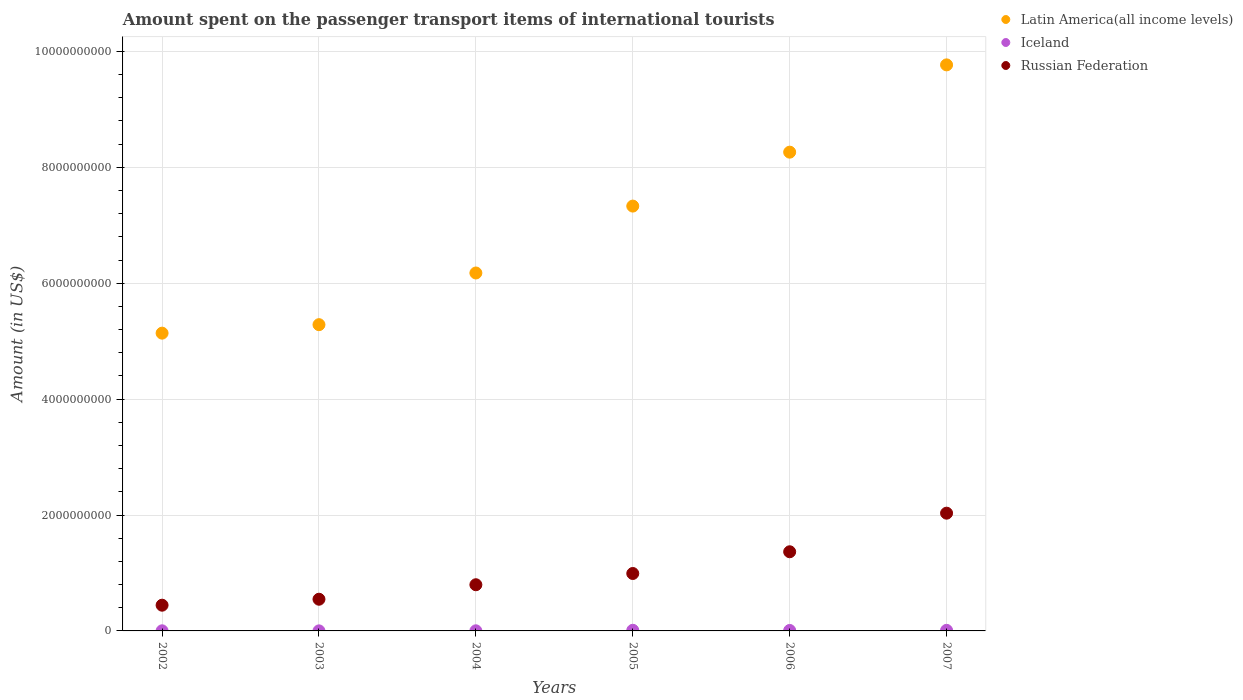How many different coloured dotlines are there?
Give a very brief answer. 3. What is the amount spent on the passenger transport items of international tourists in Russian Federation in 2002?
Offer a terse response. 4.44e+08. Across all years, what is the maximum amount spent on the passenger transport items of international tourists in Iceland?
Provide a succinct answer. 1.10e+07. In which year was the amount spent on the passenger transport items of international tourists in Latin America(all income levels) maximum?
Your answer should be very brief. 2007. What is the total amount spent on the passenger transport items of international tourists in Russian Federation in the graph?
Your answer should be very brief. 6.18e+09. What is the difference between the amount spent on the passenger transport items of international tourists in Latin America(all income levels) in 2003 and that in 2007?
Provide a succinct answer. -4.48e+09. What is the difference between the amount spent on the passenger transport items of international tourists in Iceland in 2006 and the amount spent on the passenger transport items of international tourists in Latin America(all income levels) in 2002?
Ensure brevity in your answer.  -5.13e+09. What is the average amount spent on the passenger transport items of international tourists in Iceland per year?
Give a very brief answer. 5.67e+06. In the year 2004, what is the difference between the amount spent on the passenger transport items of international tourists in Latin America(all income levels) and amount spent on the passenger transport items of international tourists in Iceland?
Offer a very short reply. 6.17e+09. What is the ratio of the amount spent on the passenger transport items of international tourists in Russian Federation in 2003 to that in 2004?
Keep it short and to the point. 0.69. Is the amount spent on the passenger transport items of international tourists in Russian Federation in 2003 less than that in 2007?
Your response must be concise. Yes. Is the difference between the amount spent on the passenger transport items of international tourists in Latin America(all income levels) in 2002 and 2006 greater than the difference between the amount spent on the passenger transport items of international tourists in Iceland in 2002 and 2006?
Provide a short and direct response. No. What is the difference between the highest and the second highest amount spent on the passenger transport items of international tourists in Russian Federation?
Offer a very short reply. 6.66e+08. Is the sum of the amount spent on the passenger transport items of international tourists in Iceland in 2005 and 2007 greater than the maximum amount spent on the passenger transport items of international tourists in Russian Federation across all years?
Your response must be concise. No. Is it the case that in every year, the sum of the amount spent on the passenger transport items of international tourists in Iceland and amount spent on the passenger transport items of international tourists in Russian Federation  is greater than the amount spent on the passenger transport items of international tourists in Latin America(all income levels)?
Your answer should be compact. No. Is the amount spent on the passenger transport items of international tourists in Russian Federation strictly greater than the amount spent on the passenger transport items of international tourists in Latin America(all income levels) over the years?
Make the answer very short. No. Is the amount spent on the passenger transport items of international tourists in Latin America(all income levels) strictly less than the amount spent on the passenger transport items of international tourists in Iceland over the years?
Offer a very short reply. No. How many years are there in the graph?
Ensure brevity in your answer.  6. What is the difference between two consecutive major ticks on the Y-axis?
Keep it short and to the point. 2.00e+09. Are the values on the major ticks of Y-axis written in scientific E-notation?
Ensure brevity in your answer.  No. Does the graph contain grids?
Offer a very short reply. Yes. How many legend labels are there?
Your answer should be compact. 3. How are the legend labels stacked?
Offer a terse response. Vertical. What is the title of the graph?
Ensure brevity in your answer.  Amount spent on the passenger transport items of international tourists. What is the label or title of the Y-axis?
Offer a very short reply. Amount (in US$). What is the Amount (in US$) of Latin America(all income levels) in 2002?
Offer a terse response. 5.14e+09. What is the Amount (in US$) in Russian Federation in 2002?
Offer a terse response. 4.44e+08. What is the Amount (in US$) in Latin America(all income levels) in 2003?
Ensure brevity in your answer.  5.29e+09. What is the Amount (in US$) in Iceland in 2003?
Offer a very short reply. 1.00e+06. What is the Amount (in US$) of Russian Federation in 2003?
Your response must be concise. 5.47e+08. What is the Amount (in US$) of Latin America(all income levels) in 2004?
Your answer should be compact. 6.18e+09. What is the Amount (in US$) of Iceland in 2004?
Your answer should be very brief. 2.00e+06. What is the Amount (in US$) of Russian Federation in 2004?
Offer a very short reply. 7.97e+08. What is the Amount (in US$) of Latin America(all income levels) in 2005?
Your answer should be compact. 7.33e+09. What is the Amount (in US$) of Iceland in 2005?
Your answer should be compact. 1.10e+07. What is the Amount (in US$) in Russian Federation in 2005?
Ensure brevity in your answer.  9.91e+08. What is the Amount (in US$) of Latin America(all income levels) in 2006?
Provide a short and direct response. 8.26e+09. What is the Amount (in US$) in Iceland in 2006?
Offer a very short reply. 8.00e+06. What is the Amount (in US$) of Russian Federation in 2006?
Offer a terse response. 1.37e+09. What is the Amount (in US$) of Latin America(all income levels) in 2007?
Provide a succinct answer. 9.77e+09. What is the Amount (in US$) in Iceland in 2007?
Provide a succinct answer. 1.00e+07. What is the Amount (in US$) in Russian Federation in 2007?
Offer a terse response. 2.03e+09. Across all years, what is the maximum Amount (in US$) in Latin America(all income levels)?
Ensure brevity in your answer.  9.77e+09. Across all years, what is the maximum Amount (in US$) of Iceland?
Your answer should be very brief. 1.10e+07. Across all years, what is the maximum Amount (in US$) in Russian Federation?
Provide a short and direct response. 2.03e+09. Across all years, what is the minimum Amount (in US$) in Latin America(all income levels)?
Ensure brevity in your answer.  5.14e+09. Across all years, what is the minimum Amount (in US$) in Russian Federation?
Make the answer very short. 4.44e+08. What is the total Amount (in US$) in Latin America(all income levels) in the graph?
Your response must be concise. 4.20e+1. What is the total Amount (in US$) in Iceland in the graph?
Ensure brevity in your answer.  3.40e+07. What is the total Amount (in US$) in Russian Federation in the graph?
Offer a terse response. 6.18e+09. What is the difference between the Amount (in US$) in Latin America(all income levels) in 2002 and that in 2003?
Your answer should be compact. -1.46e+08. What is the difference between the Amount (in US$) of Russian Federation in 2002 and that in 2003?
Your answer should be very brief. -1.03e+08. What is the difference between the Amount (in US$) in Latin America(all income levels) in 2002 and that in 2004?
Ensure brevity in your answer.  -1.04e+09. What is the difference between the Amount (in US$) in Iceland in 2002 and that in 2004?
Make the answer very short. 0. What is the difference between the Amount (in US$) in Russian Federation in 2002 and that in 2004?
Offer a terse response. -3.53e+08. What is the difference between the Amount (in US$) of Latin America(all income levels) in 2002 and that in 2005?
Offer a very short reply. -2.19e+09. What is the difference between the Amount (in US$) of Iceland in 2002 and that in 2005?
Ensure brevity in your answer.  -9.00e+06. What is the difference between the Amount (in US$) in Russian Federation in 2002 and that in 2005?
Provide a short and direct response. -5.47e+08. What is the difference between the Amount (in US$) in Latin America(all income levels) in 2002 and that in 2006?
Make the answer very short. -3.12e+09. What is the difference between the Amount (in US$) in Iceland in 2002 and that in 2006?
Provide a succinct answer. -6.00e+06. What is the difference between the Amount (in US$) of Russian Federation in 2002 and that in 2006?
Provide a short and direct response. -9.22e+08. What is the difference between the Amount (in US$) of Latin America(all income levels) in 2002 and that in 2007?
Ensure brevity in your answer.  -4.63e+09. What is the difference between the Amount (in US$) in Iceland in 2002 and that in 2007?
Make the answer very short. -8.00e+06. What is the difference between the Amount (in US$) in Russian Federation in 2002 and that in 2007?
Keep it short and to the point. -1.59e+09. What is the difference between the Amount (in US$) in Latin America(all income levels) in 2003 and that in 2004?
Your answer should be compact. -8.92e+08. What is the difference between the Amount (in US$) of Iceland in 2003 and that in 2004?
Give a very brief answer. -1.00e+06. What is the difference between the Amount (in US$) of Russian Federation in 2003 and that in 2004?
Keep it short and to the point. -2.50e+08. What is the difference between the Amount (in US$) of Latin America(all income levels) in 2003 and that in 2005?
Your answer should be very brief. -2.05e+09. What is the difference between the Amount (in US$) of Iceland in 2003 and that in 2005?
Ensure brevity in your answer.  -1.00e+07. What is the difference between the Amount (in US$) of Russian Federation in 2003 and that in 2005?
Your response must be concise. -4.44e+08. What is the difference between the Amount (in US$) of Latin America(all income levels) in 2003 and that in 2006?
Give a very brief answer. -2.98e+09. What is the difference between the Amount (in US$) in Iceland in 2003 and that in 2006?
Your answer should be compact. -7.00e+06. What is the difference between the Amount (in US$) of Russian Federation in 2003 and that in 2006?
Ensure brevity in your answer.  -8.19e+08. What is the difference between the Amount (in US$) in Latin America(all income levels) in 2003 and that in 2007?
Offer a very short reply. -4.48e+09. What is the difference between the Amount (in US$) of Iceland in 2003 and that in 2007?
Offer a terse response. -9.00e+06. What is the difference between the Amount (in US$) in Russian Federation in 2003 and that in 2007?
Your answer should be compact. -1.48e+09. What is the difference between the Amount (in US$) in Latin America(all income levels) in 2004 and that in 2005?
Provide a short and direct response. -1.15e+09. What is the difference between the Amount (in US$) in Iceland in 2004 and that in 2005?
Keep it short and to the point. -9.00e+06. What is the difference between the Amount (in US$) of Russian Federation in 2004 and that in 2005?
Give a very brief answer. -1.94e+08. What is the difference between the Amount (in US$) of Latin America(all income levels) in 2004 and that in 2006?
Offer a very short reply. -2.09e+09. What is the difference between the Amount (in US$) of Iceland in 2004 and that in 2006?
Your answer should be very brief. -6.00e+06. What is the difference between the Amount (in US$) in Russian Federation in 2004 and that in 2006?
Offer a terse response. -5.69e+08. What is the difference between the Amount (in US$) in Latin America(all income levels) in 2004 and that in 2007?
Ensure brevity in your answer.  -3.59e+09. What is the difference between the Amount (in US$) in Iceland in 2004 and that in 2007?
Your response must be concise. -8.00e+06. What is the difference between the Amount (in US$) of Russian Federation in 2004 and that in 2007?
Your response must be concise. -1.24e+09. What is the difference between the Amount (in US$) of Latin America(all income levels) in 2005 and that in 2006?
Your answer should be very brief. -9.31e+08. What is the difference between the Amount (in US$) of Iceland in 2005 and that in 2006?
Make the answer very short. 3.00e+06. What is the difference between the Amount (in US$) of Russian Federation in 2005 and that in 2006?
Offer a very short reply. -3.75e+08. What is the difference between the Amount (in US$) of Latin America(all income levels) in 2005 and that in 2007?
Keep it short and to the point. -2.44e+09. What is the difference between the Amount (in US$) in Iceland in 2005 and that in 2007?
Keep it short and to the point. 1.00e+06. What is the difference between the Amount (in US$) of Russian Federation in 2005 and that in 2007?
Your answer should be compact. -1.04e+09. What is the difference between the Amount (in US$) in Latin America(all income levels) in 2006 and that in 2007?
Offer a terse response. -1.51e+09. What is the difference between the Amount (in US$) in Iceland in 2006 and that in 2007?
Offer a terse response. -2.00e+06. What is the difference between the Amount (in US$) in Russian Federation in 2006 and that in 2007?
Give a very brief answer. -6.66e+08. What is the difference between the Amount (in US$) in Latin America(all income levels) in 2002 and the Amount (in US$) in Iceland in 2003?
Offer a terse response. 5.14e+09. What is the difference between the Amount (in US$) in Latin America(all income levels) in 2002 and the Amount (in US$) in Russian Federation in 2003?
Keep it short and to the point. 4.59e+09. What is the difference between the Amount (in US$) of Iceland in 2002 and the Amount (in US$) of Russian Federation in 2003?
Your answer should be compact. -5.45e+08. What is the difference between the Amount (in US$) in Latin America(all income levels) in 2002 and the Amount (in US$) in Iceland in 2004?
Offer a very short reply. 5.14e+09. What is the difference between the Amount (in US$) of Latin America(all income levels) in 2002 and the Amount (in US$) of Russian Federation in 2004?
Keep it short and to the point. 4.34e+09. What is the difference between the Amount (in US$) in Iceland in 2002 and the Amount (in US$) in Russian Federation in 2004?
Offer a very short reply. -7.95e+08. What is the difference between the Amount (in US$) in Latin America(all income levels) in 2002 and the Amount (in US$) in Iceland in 2005?
Your answer should be very brief. 5.13e+09. What is the difference between the Amount (in US$) of Latin America(all income levels) in 2002 and the Amount (in US$) of Russian Federation in 2005?
Ensure brevity in your answer.  4.15e+09. What is the difference between the Amount (in US$) of Iceland in 2002 and the Amount (in US$) of Russian Federation in 2005?
Your answer should be very brief. -9.89e+08. What is the difference between the Amount (in US$) of Latin America(all income levels) in 2002 and the Amount (in US$) of Iceland in 2006?
Provide a short and direct response. 5.13e+09. What is the difference between the Amount (in US$) in Latin America(all income levels) in 2002 and the Amount (in US$) in Russian Federation in 2006?
Your answer should be compact. 3.77e+09. What is the difference between the Amount (in US$) in Iceland in 2002 and the Amount (in US$) in Russian Federation in 2006?
Offer a very short reply. -1.36e+09. What is the difference between the Amount (in US$) in Latin America(all income levels) in 2002 and the Amount (in US$) in Iceland in 2007?
Your answer should be very brief. 5.13e+09. What is the difference between the Amount (in US$) of Latin America(all income levels) in 2002 and the Amount (in US$) of Russian Federation in 2007?
Your response must be concise. 3.11e+09. What is the difference between the Amount (in US$) in Iceland in 2002 and the Amount (in US$) in Russian Federation in 2007?
Keep it short and to the point. -2.03e+09. What is the difference between the Amount (in US$) of Latin America(all income levels) in 2003 and the Amount (in US$) of Iceland in 2004?
Provide a short and direct response. 5.28e+09. What is the difference between the Amount (in US$) of Latin America(all income levels) in 2003 and the Amount (in US$) of Russian Federation in 2004?
Your response must be concise. 4.49e+09. What is the difference between the Amount (in US$) of Iceland in 2003 and the Amount (in US$) of Russian Federation in 2004?
Provide a succinct answer. -7.96e+08. What is the difference between the Amount (in US$) in Latin America(all income levels) in 2003 and the Amount (in US$) in Iceland in 2005?
Provide a short and direct response. 5.27e+09. What is the difference between the Amount (in US$) in Latin America(all income levels) in 2003 and the Amount (in US$) in Russian Federation in 2005?
Offer a very short reply. 4.29e+09. What is the difference between the Amount (in US$) in Iceland in 2003 and the Amount (in US$) in Russian Federation in 2005?
Provide a succinct answer. -9.90e+08. What is the difference between the Amount (in US$) of Latin America(all income levels) in 2003 and the Amount (in US$) of Iceland in 2006?
Provide a succinct answer. 5.28e+09. What is the difference between the Amount (in US$) in Latin America(all income levels) in 2003 and the Amount (in US$) in Russian Federation in 2006?
Provide a succinct answer. 3.92e+09. What is the difference between the Amount (in US$) in Iceland in 2003 and the Amount (in US$) in Russian Federation in 2006?
Keep it short and to the point. -1.36e+09. What is the difference between the Amount (in US$) in Latin America(all income levels) in 2003 and the Amount (in US$) in Iceland in 2007?
Your answer should be compact. 5.28e+09. What is the difference between the Amount (in US$) of Latin America(all income levels) in 2003 and the Amount (in US$) of Russian Federation in 2007?
Ensure brevity in your answer.  3.25e+09. What is the difference between the Amount (in US$) in Iceland in 2003 and the Amount (in US$) in Russian Federation in 2007?
Your response must be concise. -2.03e+09. What is the difference between the Amount (in US$) in Latin America(all income levels) in 2004 and the Amount (in US$) in Iceland in 2005?
Give a very brief answer. 6.17e+09. What is the difference between the Amount (in US$) of Latin America(all income levels) in 2004 and the Amount (in US$) of Russian Federation in 2005?
Provide a succinct answer. 5.19e+09. What is the difference between the Amount (in US$) of Iceland in 2004 and the Amount (in US$) of Russian Federation in 2005?
Make the answer very short. -9.89e+08. What is the difference between the Amount (in US$) of Latin America(all income levels) in 2004 and the Amount (in US$) of Iceland in 2006?
Offer a very short reply. 6.17e+09. What is the difference between the Amount (in US$) in Latin America(all income levels) in 2004 and the Amount (in US$) in Russian Federation in 2006?
Ensure brevity in your answer.  4.81e+09. What is the difference between the Amount (in US$) in Iceland in 2004 and the Amount (in US$) in Russian Federation in 2006?
Give a very brief answer. -1.36e+09. What is the difference between the Amount (in US$) of Latin America(all income levels) in 2004 and the Amount (in US$) of Iceland in 2007?
Give a very brief answer. 6.17e+09. What is the difference between the Amount (in US$) of Latin America(all income levels) in 2004 and the Amount (in US$) of Russian Federation in 2007?
Ensure brevity in your answer.  4.14e+09. What is the difference between the Amount (in US$) of Iceland in 2004 and the Amount (in US$) of Russian Federation in 2007?
Make the answer very short. -2.03e+09. What is the difference between the Amount (in US$) of Latin America(all income levels) in 2005 and the Amount (in US$) of Iceland in 2006?
Keep it short and to the point. 7.32e+09. What is the difference between the Amount (in US$) in Latin America(all income levels) in 2005 and the Amount (in US$) in Russian Federation in 2006?
Your response must be concise. 5.97e+09. What is the difference between the Amount (in US$) of Iceland in 2005 and the Amount (in US$) of Russian Federation in 2006?
Your response must be concise. -1.36e+09. What is the difference between the Amount (in US$) of Latin America(all income levels) in 2005 and the Amount (in US$) of Iceland in 2007?
Provide a short and direct response. 7.32e+09. What is the difference between the Amount (in US$) in Latin America(all income levels) in 2005 and the Amount (in US$) in Russian Federation in 2007?
Make the answer very short. 5.30e+09. What is the difference between the Amount (in US$) in Iceland in 2005 and the Amount (in US$) in Russian Federation in 2007?
Your answer should be compact. -2.02e+09. What is the difference between the Amount (in US$) of Latin America(all income levels) in 2006 and the Amount (in US$) of Iceland in 2007?
Keep it short and to the point. 8.25e+09. What is the difference between the Amount (in US$) in Latin America(all income levels) in 2006 and the Amount (in US$) in Russian Federation in 2007?
Give a very brief answer. 6.23e+09. What is the difference between the Amount (in US$) in Iceland in 2006 and the Amount (in US$) in Russian Federation in 2007?
Make the answer very short. -2.02e+09. What is the average Amount (in US$) in Latin America(all income levels) per year?
Your response must be concise. 6.99e+09. What is the average Amount (in US$) in Iceland per year?
Your answer should be compact. 5.67e+06. What is the average Amount (in US$) of Russian Federation per year?
Provide a succinct answer. 1.03e+09. In the year 2002, what is the difference between the Amount (in US$) in Latin America(all income levels) and Amount (in US$) in Iceland?
Ensure brevity in your answer.  5.14e+09. In the year 2002, what is the difference between the Amount (in US$) in Latin America(all income levels) and Amount (in US$) in Russian Federation?
Your response must be concise. 4.69e+09. In the year 2002, what is the difference between the Amount (in US$) of Iceland and Amount (in US$) of Russian Federation?
Offer a very short reply. -4.42e+08. In the year 2003, what is the difference between the Amount (in US$) in Latin America(all income levels) and Amount (in US$) in Iceland?
Make the answer very short. 5.28e+09. In the year 2003, what is the difference between the Amount (in US$) in Latin America(all income levels) and Amount (in US$) in Russian Federation?
Your response must be concise. 4.74e+09. In the year 2003, what is the difference between the Amount (in US$) of Iceland and Amount (in US$) of Russian Federation?
Provide a succinct answer. -5.46e+08. In the year 2004, what is the difference between the Amount (in US$) in Latin America(all income levels) and Amount (in US$) in Iceland?
Give a very brief answer. 6.17e+09. In the year 2004, what is the difference between the Amount (in US$) of Latin America(all income levels) and Amount (in US$) of Russian Federation?
Ensure brevity in your answer.  5.38e+09. In the year 2004, what is the difference between the Amount (in US$) in Iceland and Amount (in US$) in Russian Federation?
Offer a terse response. -7.95e+08. In the year 2005, what is the difference between the Amount (in US$) of Latin America(all income levels) and Amount (in US$) of Iceland?
Your response must be concise. 7.32e+09. In the year 2005, what is the difference between the Amount (in US$) in Latin America(all income levels) and Amount (in US$) in Russian Federation?
Provide a succinct answer. 6.34e+09. In the year 2005, what is the difference between the Amount (in US$) in Iceland and Amount (in US$) in Russian Federation?
Ensure brevity in your answer.  -9.80e+08. In the year 2006, what is the difference between the Amount (in US$) of Latin America(all income levels) and Amount (in US$) of Iceland?
Offer a very short reply. 8.25e+09. In the year 2006, what is the difference between the Amount (in US$) in Latin America(all income levels) and Amount (in US$) in Russian Federation?
Keep it short and to the point. 6.90e+09. In the year 2006, what is the difference between the Amount (in US$) in Iceland and Amount (in US$) in Russian Federation?
Your answer should be compact. -1.36e+09. In the year 2007, what is the difference between the Amount (in US$) of Latin America(all income levels) and Amount (in US$) of Iceland?
Provide a succinct answer. 9.76e+09. In the year 2007, what is the difference between the Amount (in US$) of Latin America(all income levels) and Amount (in US$) of Russian Federation?
Your answer should be very brief. 7.74e+09. In the year 2007, what is the difference between the Amount (in US$) in Iceland and Amount (in US$) in Russian Federation?
Your answer should be compact. -2.02e+09. What is the ratio of the Amount (in US$) of Latin America(all income levels) in 2002 to that in 2003?
Give a very brief answer. 0.97. What is the ratio of the Amount (in US$) in Russian Federation in 2002 to that in 2003?
Offer a very short reply. 0.81. What is the ratio of the Amount (in US$) of Latin America(all income levels) in 2002 to that in 2004?
Offer a terse response. 0.83. What is the ratio of the Amount (in US$) in Iceland in 2002 to that in 2004?
Your answer should be compact. 1. What is the ratio of the Amount (in US$) of Russian Federation in 2002 to that in 2004?
Keep it short and to the point. 0.56. What is the ratio of the Amount (in US$) of Latin America(all income levels) in 2002 to that in 2005?
Ensure brevity in your answer.  0.7. What is the ratio of the Amount (in US$) in Iceland in 2002 to that in 2005?
Your answer should be very brief. 0.18. What is the ratio of the Amount (in US$) in Russian Federation in 2002 to that in 2005?
Offer a very short reply. 0.45. What is the ratio of the Amount (in US$) in Latin America(all income levels) in 2002 to that in 2006?
Your answer should be very brief. 0.62. What is the ratio of the Amount (in US$) in Iceland in 2002 to that in 2006?
Keep it short and to the point. 0.25. What is the ratio of the Amount (in US$) of Russian Federation in 2002 to that in 2006?
Keep it short and to the point. 0.33. What is the ratio of the Amount (in US$) in Latin America(all income levels) in 2002 to that in 2007?
Give a very brief answer. 0.53. What is the ratio of the Amount (in US$) in Iceland in 2002 to that in 2007?
Your answer should be compact. 0.2. What is the ratio of the Amount (in US$) in Russian Federation in 2002 to that in 2007?
Provide a short and direct response. 0.22. What is the ratio of the Amount (in US$) of Latin America(all income levels) in 2003 to that in 2004?
Make the answer very short. 0.86. What is the ratio of the Amount (in US$) of Russian Federation in 2003 to that in 2004?
Your answer should be very brief. 0.69. What is the ratio of the Amount (in US$) in Latin America(all income levels) in 2003 to that in 2005?
Keep it short and to the point. 0.72. What is the ratio of the Amount (in US$) in Iceland in 2003 to that in 2005?
Offer a terse response. 0.09. What is the ratio of the Amount (in US$) of Russian Federation in 2003 to that in 2005?
Ensure brevity in your answer.  0.55. What is the ratio of the Amount (in US$) of Latin America(all income levels) in 2003 to that in 2006?
Provide a short and direct response. 0.64. What is the ratio of the Amount (in US$) in Iceland in 2003 to that in 2006?
Give a very brief answer. 0.12. What is the ratio of the Amount (in US$) in Russian Federation in 2003 to that in 2006?
Your response must be concise. 0.4. What is the ratio of the Amount (in US$) in Latin America(all income levels) in 2003 to that in 2007?
Provide a succinct answer. 0.54. What is the ratio of the Amount (in US$) of Iceland in 2003 to that in 2007?
Offer a terse response. 0.1. What is the ratio of the Amount (in US$) in Russian Federation in 2003 to that in 2007?
Your answer should be very brief. 0.27. What is the ratio of the Amount (in US$) in Latin America(all income levels) in 2004 to that in 2005?
Ensure brevity in your answer.  0.84. What is the ratio of the Amount (in US$) of Iceland in 2004 to that in 2005?
Ensure brevity in your answer.  0.18. What is the ratio of the Amount (in US$) in Russian Federation in 2004 to that in 2005?
Make the answer very short. 0.8. What is the ratio of the Amount (in US$) in Latin America(all income levels) in 2004 to that in 2006?
Keep it short and to the point. 0.75. What is the ratio of the Amount (in US$) of Iceland in 2004 to that in 2006?
Provide a succinct answer. 0.25. What is the ratio of the Amount (in US$) in Russian Federation in 2004 to that in 2006?
Give a very brief answer. 0.58. What is the ratio of the Amount (in US$) of Latin America(all income levels) in 2004 to that in 2007?
Provide a succinct answer. 0.63. What is the ratio of the Amount (in US$) of Russian Federation in 2004 to that in 2007?
Your response must be concise. 0.39. What is the ratio of the Amount (in US$) in Latin America(all income levels) in 2005 to that in 2006?
Ensure brevity in your answer.  0.89. What is the ratio of the Amount (in US$) in Iceland in 2005 to that in 2006?
Provide a short and direct response. 1.38. What is the ratio of the Amount (in US$) in Russian Federation in 2005 to that in 2006?
Offer a terse response. 0.73. What is the ratio of the Amount (in US$) in Latin America(all income levels) in 2005 to that in 2007?
Provide a succinct answer. 0.75. What is the ratio of the Amount (in US$) of Russian Federation in 2005 to that in 2007?
Make the answer very short. 0.49. What is the ratio of the Amount (in US$) of Latin America(all income levels) in 2006 to that in 2007?
Provide a short and direct response. 0.85. What is the ratio of the Amount (in US$) in Iceland in 2006 to that in 2007?
Keep it short and to the point. 0.8. What is the ratio of the Amount (in US$) of Russian Federation in 2006 to that in 2007?
Your response must be concise. 0.67. What is the difference between the highest and the second highest Amount (in US$) in Latin America(all income levels)?
Your response must be concise. 1.51e+09. What is the difference between the highest and the second highest Amount (in US$) in Russian Federation?
Your response must be concise. 6.66e+08. What is the difference between the highest and the lowest Amount (in US$) of Latin America(all income levels)?
Provide a short and direct response. 4.63e+09. What is the difference between the highest and the lowest Amount (in US$) of Russian Federation?
Make the answer very short. 1.59e+09. 